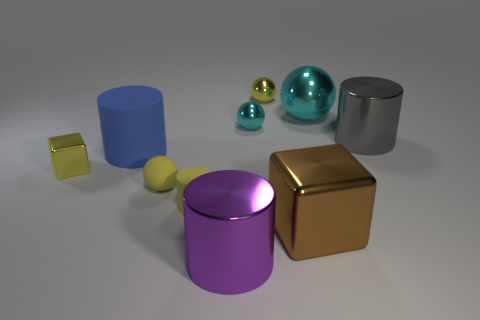Which of the objects in the image appears to be the smoothest? Among the objects, the teal sphere appears to be the smoothest, with its surface reflecting the environment with minimal distortion. 